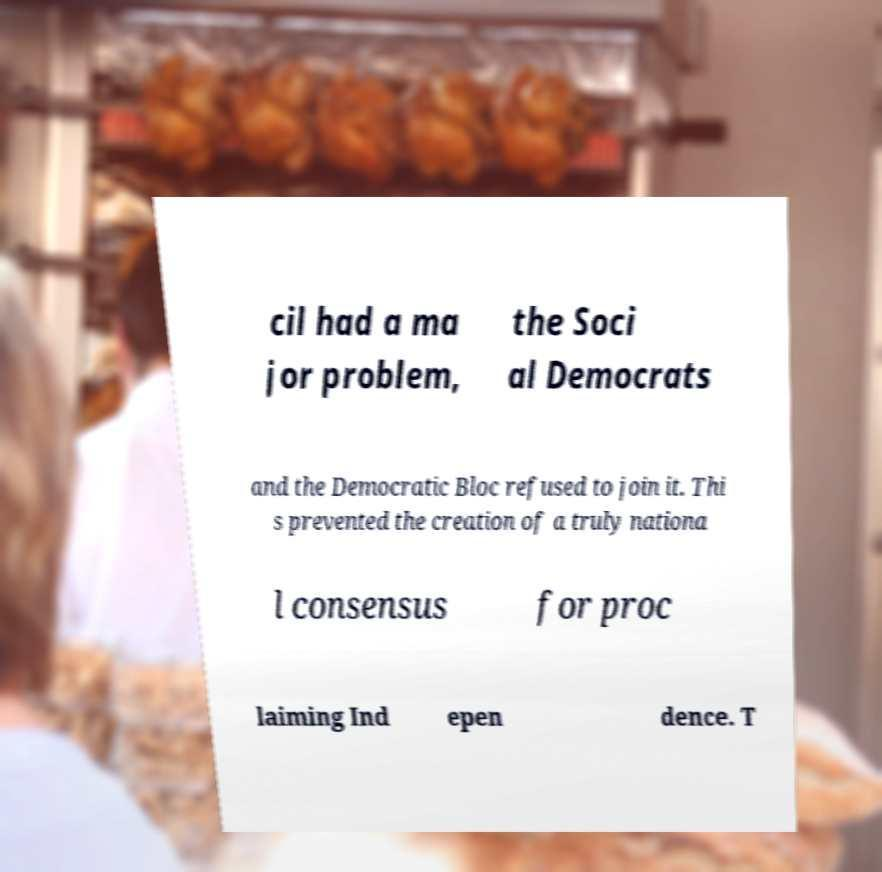Please read and relay the text visible in this image. What does it say? cil had a ma jor problem, the Soci al Democrats and the Democratic Bloc refused to join it. Thi s prevented the creation of a truly nationa l consensus for proc laiming Ind epen dence. T 